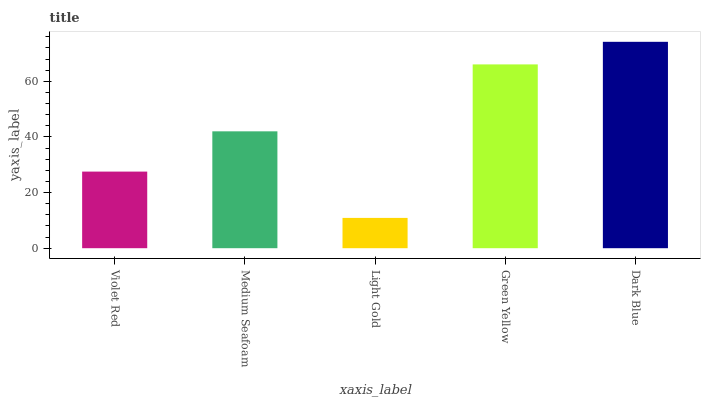Is Medium Seafoam the minimum?
Answer yes or no. No. Is Medium Seafoam the maximum?
Answer yes or no. No. Is Medium Seafoam greater than Violet Red?
Answer yes or no. Yes. Is Violet Red less than Medium Seafoam?
Answer yes or no. Yes. Is Violet Red greater than Medium Seafoam?
Answer yes or no. No. Is Medium Seafoam less than Violet Red?
Answer yes or no. No. Is Medium Seafoam the high median?
Answer yes or no. Yes. Is Medium Seafoam the low median?
Answer yes or no. Yes. Is Green Yellow the high median?
Answer yes or no. No. Is Dark Blue the low median?
Answer yes or no. No. 